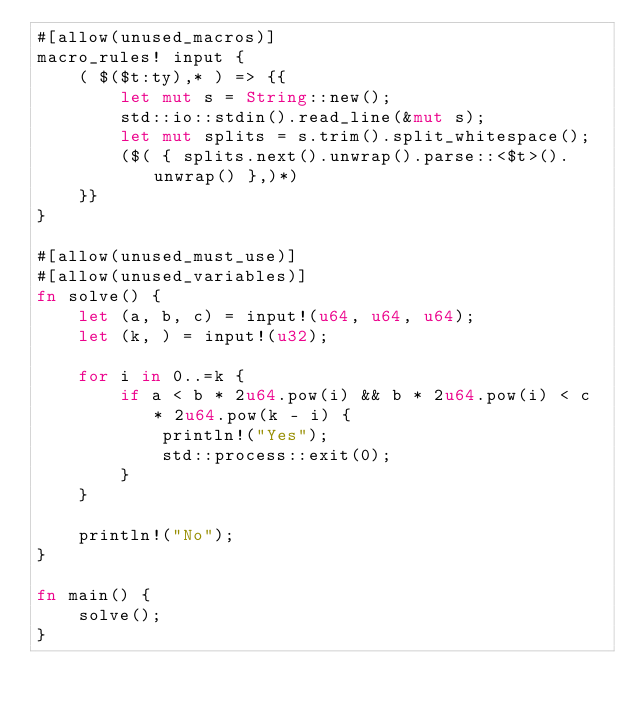<code> <loc_0><loc_0><loc_500><loc_500><_Rust_>#[allow(unused_macros)]
macro_rules! input {
    ( $($t:ty),* ) => {{
        let mut s = String::new();
        std::io::stdin().read_line(&mut s);
        let mut splits = s.trim().split_whitespace();
        ($( { splits.next().unwrap().parse::<$t>().unwrap() },)*)
    }}
}

#[allow(unused_must_use)]
#[allow(unused_variables)]
fn solve() {
    let (a, b, c) = input!(u64, u64, u64);
    let (k, ) = input!(u32);

    for i in 0..=k {
        if a < b * 2u64.pow(i) && b * 2u64.pow(i) < c * 2u64.pow(k - i) {
            println!("Yes");
            std::process::exit(0);
        }
    }

    println!("No");
}

fn main() {
    solve();
}
</code> 